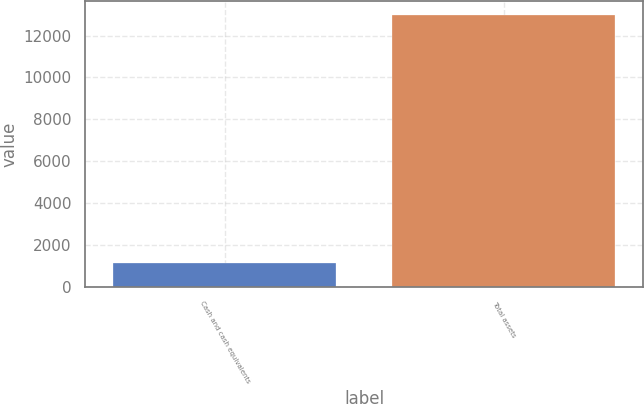Convert chart. <chart><loc_0><loc_0><loc_500><loc_500><bar_chart><fcel>Cash and cash equivalents<fcel>Total assets<nl><fcel>1133<fcel>12991<nl></chart> 